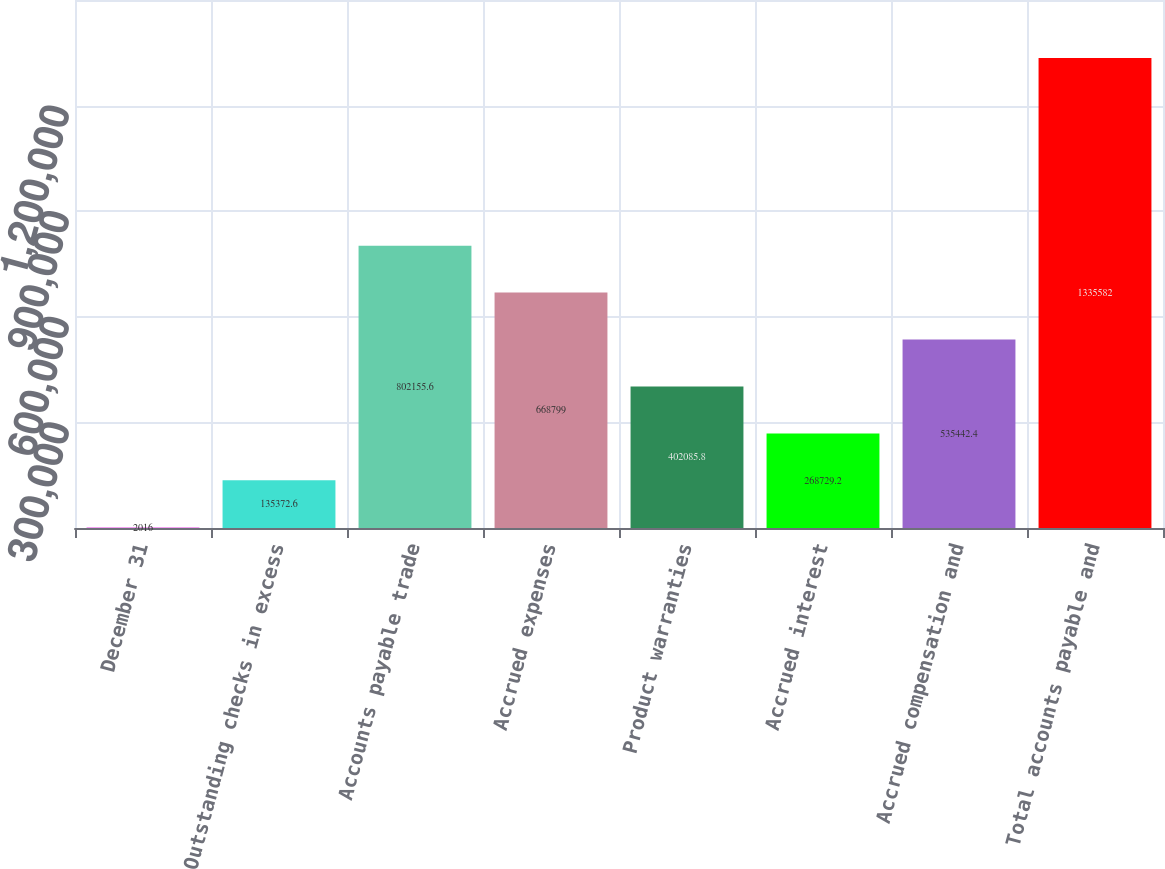<chart> <loc_0><loc_0><loc_500><loc_500><bar_chart><fcel>December 31<fcel>Outstanding checks in excess<fcel>Accounts payable trade<fcel>Accrued expenses<fcel>Product warranties<fcel>Accrued interest<fcel>Accrued compensation and<fcel>Total accounts payable and<nl><fcel>2016<fcel>135373<fcel>802156<fcel>668799<fcel>402086<fcel>268729<fcel>535442<fcel>1.33558e+06<nl></chart> 